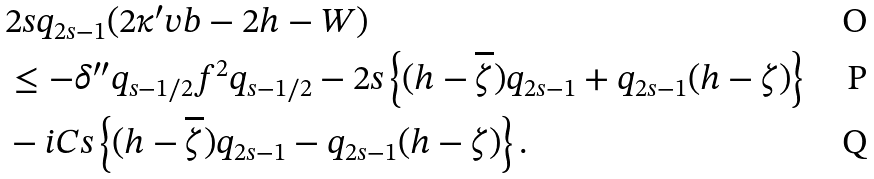Convert formula to latex. <formula><loc_0><loc_0><loc_500><loc_500>& 2 s q _ { 2 s - 1 } ( 2 \kappa ^ { \prime } v b - 2 h - W ) \\ & \leq - \delta ^ { \prime \prime } q _ { s - 1 / 2 } f ^ { 2 } q _ { s - 1 / 2 } - 2 s \left \{ ( h - \overline { \zeta } ) q _ { 2 s - 1 } + q _ { 2 s - 1 } ( h - \zeta ) \right \} \\ & - i C s \left \{ ( h - \overline { \zeta } ) q _ { 2 s - 1 } - q _ { 2 s - 1 } ( h - \zeta ) \right \} .</formula> 